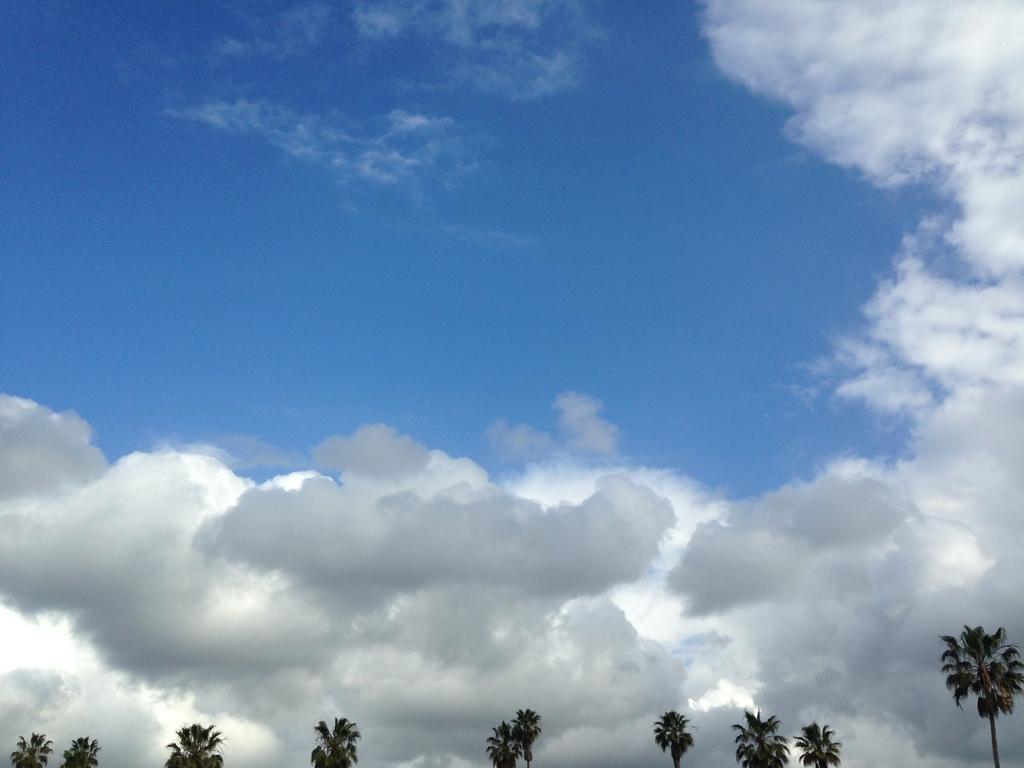Can you describe this image briefly? In this picture I can see some trees and cloudy sky. 